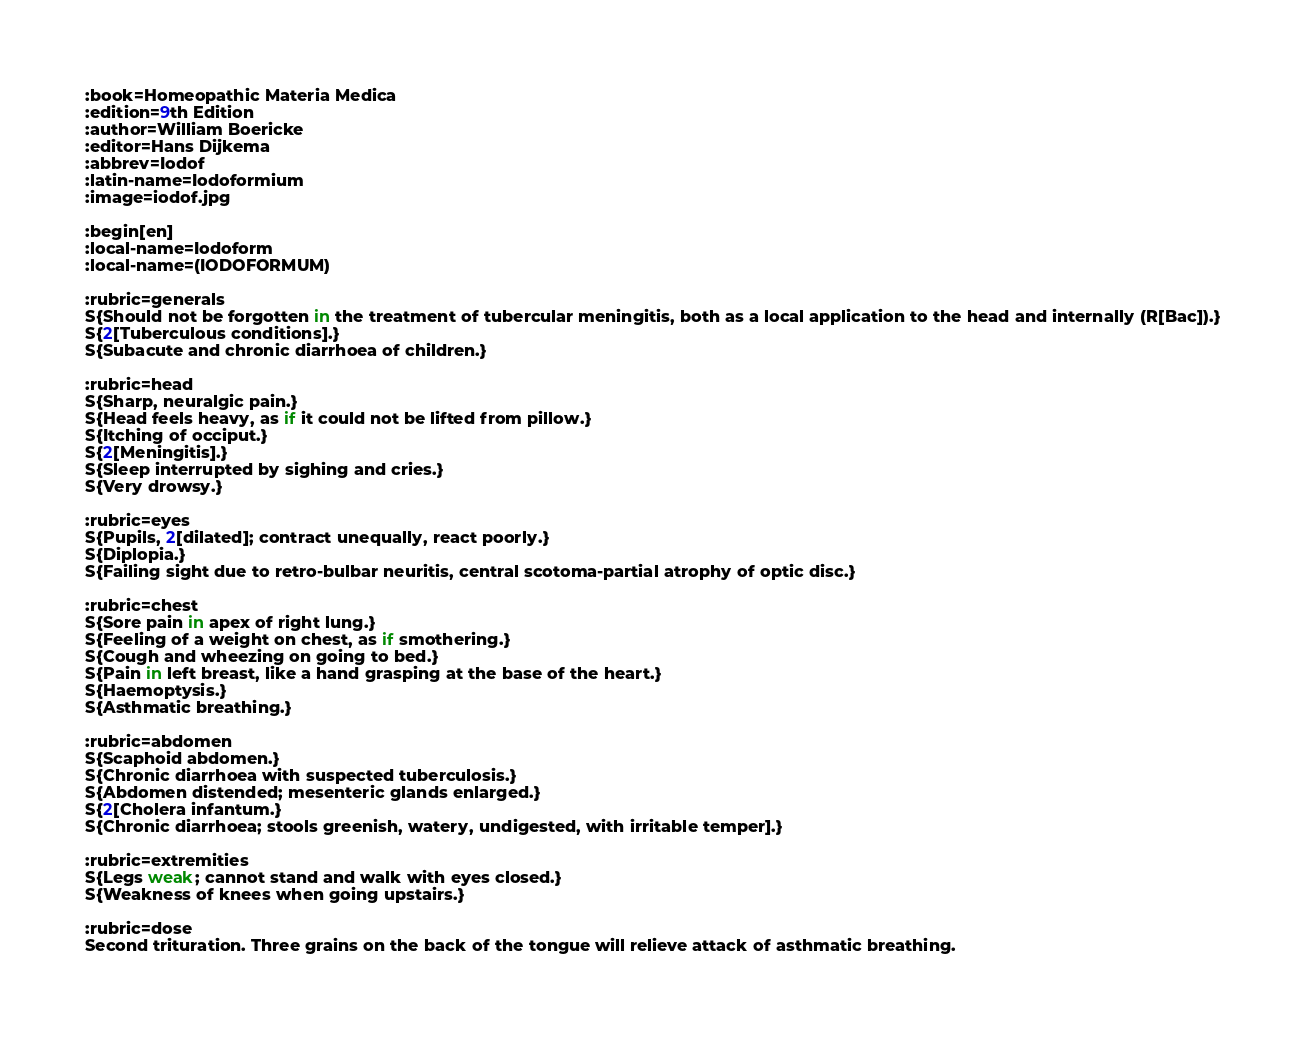Convert code to text. <code><loc_0><loc_0><loc_500><loc_500><_ObjectiveC_>:book=Homeopathic Materia Medica
:edition=9th Edition
:author=William Boericke
:editor=Hans Dijkema
:abbrev=Iodof
:latin-name=Iodoformium
:image=iodof.jpg

:begin[en]
:local-name=Iodoform
:local-name=(IODOFORMUM)

:rubric=generals
S{Should not be forgotten in the treatment of tubercular meningitis, both as a local application to the head and internally (R[Bac]).}
S{2[Tuberculous conditions].}
S{Subacute and chronic diarrhoea of children.}

:rubric=head
S{Sharp, neuralgic pain.}
S{Head feels heavy, as if it could not be lifted from pillow.}
S{Itching of occiput.}
S{2[Meningitis].}
S{Sleep interrupted by sighing and cries.}
S{Very drowsy.}

:rubric=eyes
S{Pupils, 2[dilated]; contract unequally, react poorly.}
S{Diplopia.}
S{Failing sight due to retro-bulbar neuritis, central scotoma-partial atrophy of optic disc.}

:rubric=chest
S{Sore pain in apex of right lung.}
S{Feeling of a weight on chest, as if smothering.}
S{Cough and wheezing on going to bed.}
S{Pain in left breast, like a hand grasping at the base of the heart.}
S{Haemoptysis.}
S{Asthmatic breathing.}

:rubric=abdomen
S{Scaphoid abdomen.}
S{Chronic diarrhoea with suspected tuberculosis.}
S{Abdomen distended; mesenteric glands enlarged.}
S{2[Cholera infantum.}
S{Chronic diarrhoea; stools greenish, watery, undigested, with irritable temper].}

:rubric=extremities
S{Legs weak; cannot stand and walk with eyes closed.}
S{Weakness of knees when going upstairs.}

:rubric=dose
Second trituration. Three grains on the back of the tongue will relieve attack of asthmatic breathing.</code> 